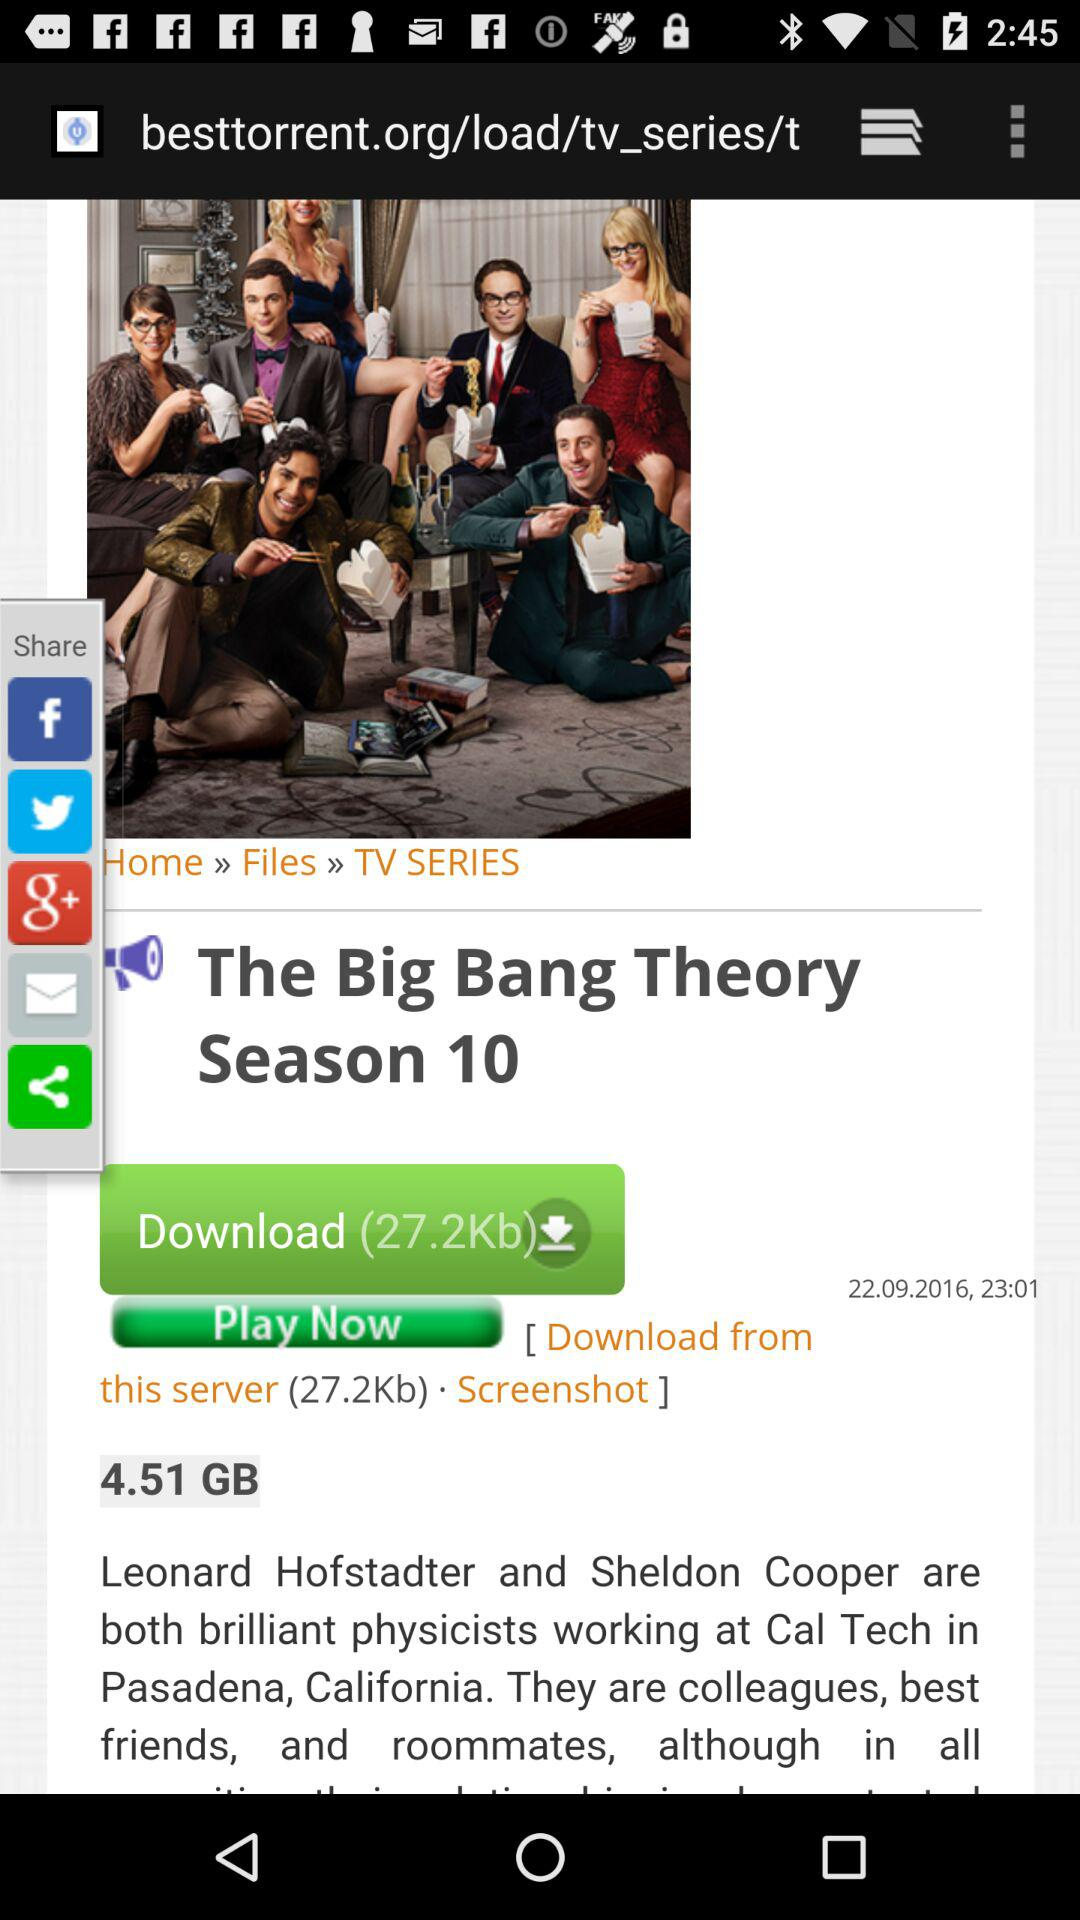What time was the series uploaded? The series was uploaded at 23:01. 